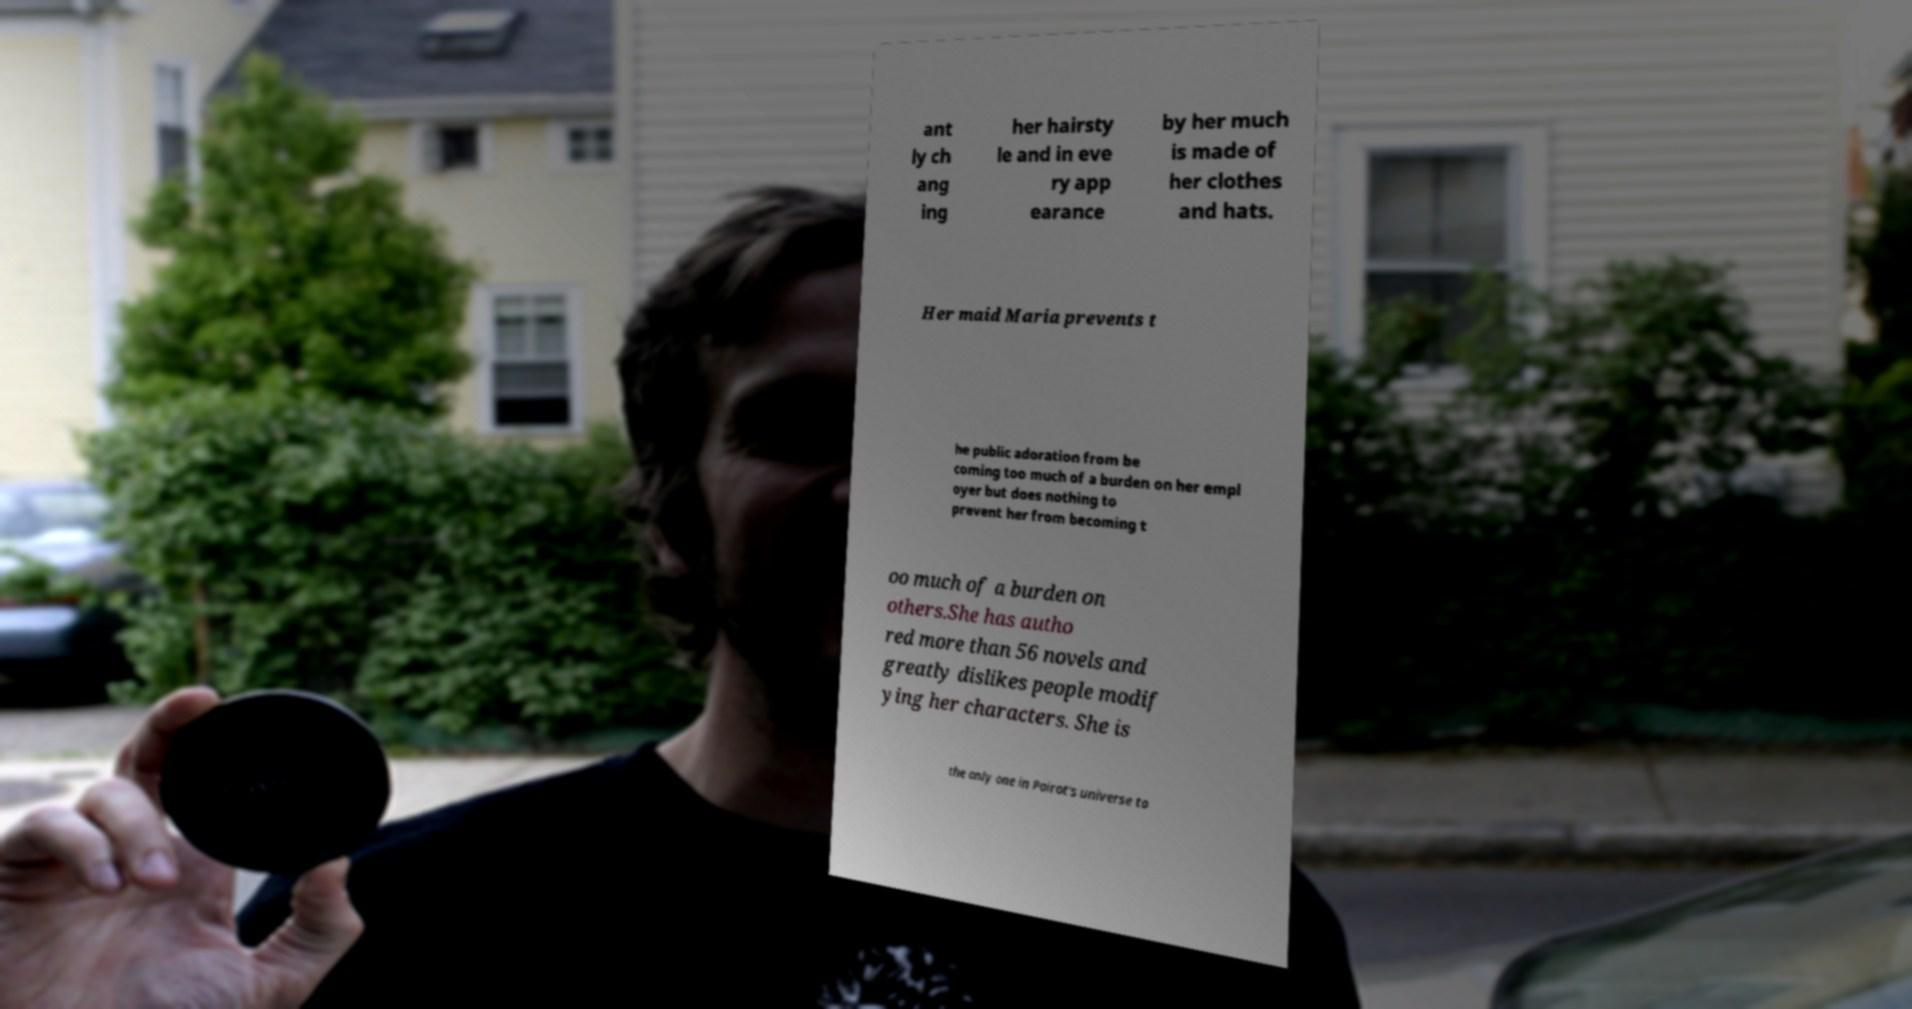Could you extract and type out the text from this image? ant ly ch ang ing her hairsty le and in eve ry app earance by her much is made of her clothes and hats. Her maid Maria prevents t he public adoration from be coming too much of a burden on her empl oyer but does nothing to prevent her from becoming t oo much of a burden on others.She has autho red more than 56 novels and greatly dislikes people modif ying her characters. She is the only one in Poirot's universe to 